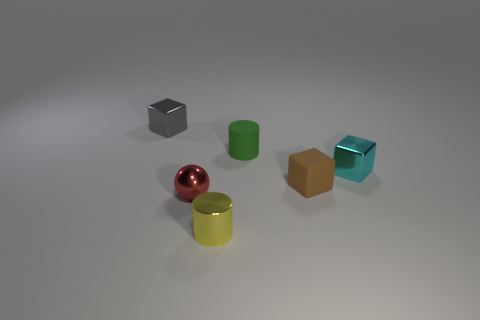How many other balls are the same color as the metallic sphere?
Make the answer very short. 0. What number of objects are small objects right of the tiny green rubber thing or large yellow cubes?
Your answer should be compact. 2. What color is the sphere that is the same material as the tiny yellow cylinder?
Keep it short and to the point. Red. Are there any cyan cylinders of the same size as the ball?
Offer a terse response. No. How many things are cyan cubes behind the red shiny thing or small shiny objects that are in front of the cyan block?
Your response must be concise. 3. What shape is the yellow metal thing that is the same size as the red object?
Keep it short and to the point. Cylinder. Is there a small red object that has the same shape as the small yellow metal thing?
Offer a terse response. No. Are there fewer large yellow matte cubes than small metal blocks?
Give a very brief answer. Yes. There is a cylinder behind the tiny red object; is its size the same as the block in front of the tiny cyan metal block?
Ensure brevity in your answer.  Yes. How many objects are either tiny green objects or small gray cubes?
Give a very brief answer. 2. 